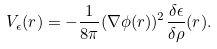Convert formula to latex. <formula><loc_0><loc_0><loc_500><loc_500>V _ { \epsilon } ( { r } ) = - \frac { 1 } { 8 \pi } ( \nabla \phi ( { r } ) ) ^ { 2 } \frac { \delta \epsilon } { \delta \rho } ( r ) .</formula> 